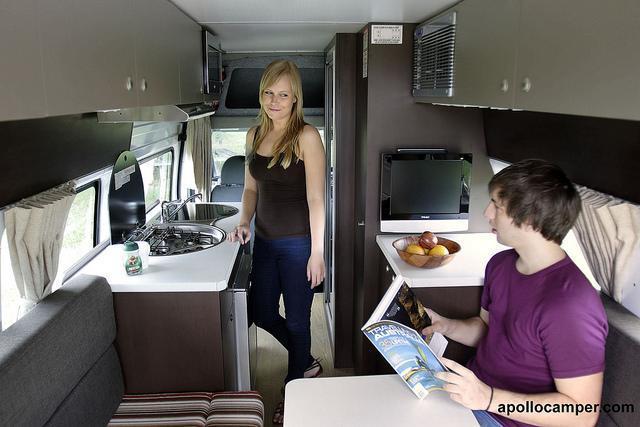How many couches are there?
Give a very brief answer. 2. How many people are in the picture?
Give a very brief answer. 2. How many giraffes are there?
Give a very brief answer. 0. 